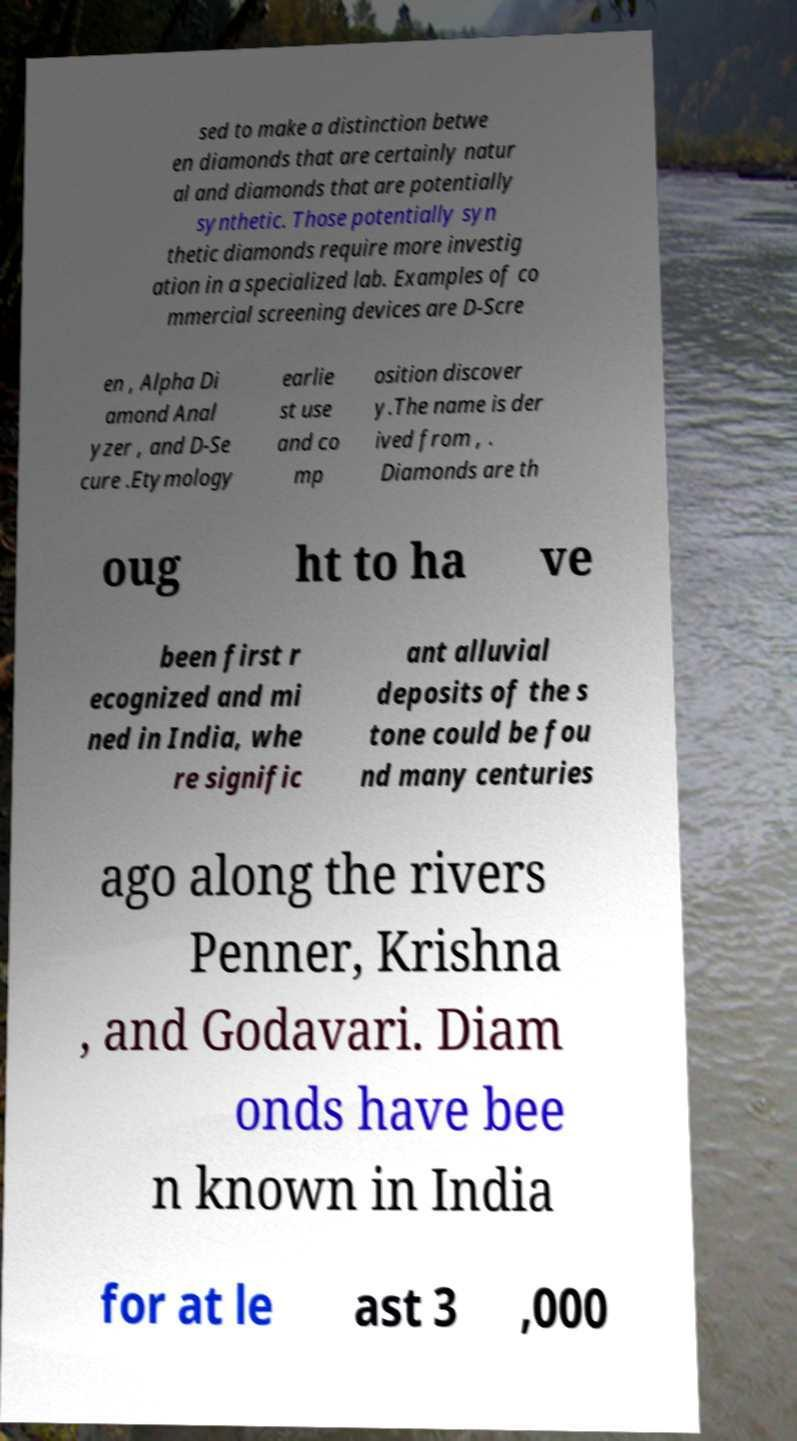Can you read and provide the text displayed in the image?This photo seems to have some interesting text. Can you extract and type it out for me? sed to make a distinction betwe en diamonds that are certainly natur al and diamonds that are potentially synthetic. Those potentially syn thetic diamonds require more investig ation in a specialized lab. Examples of co mmercial screening devices are D-Scre en , Alpha Di amond Anal yzer , and D-Se cure .Etymology earlie st use and co mp osition discover y.The name is der ived from , . Diamonds are th oug ht to ha ve been first r ecognized and mi ned in India, whe re signific ant alluvial deposits of the s tone could be fou nd many centuries ago along the rivers Penner, Krishna , and Godavari. Diam onds have bee n known in India for at le ast 3 ,000 